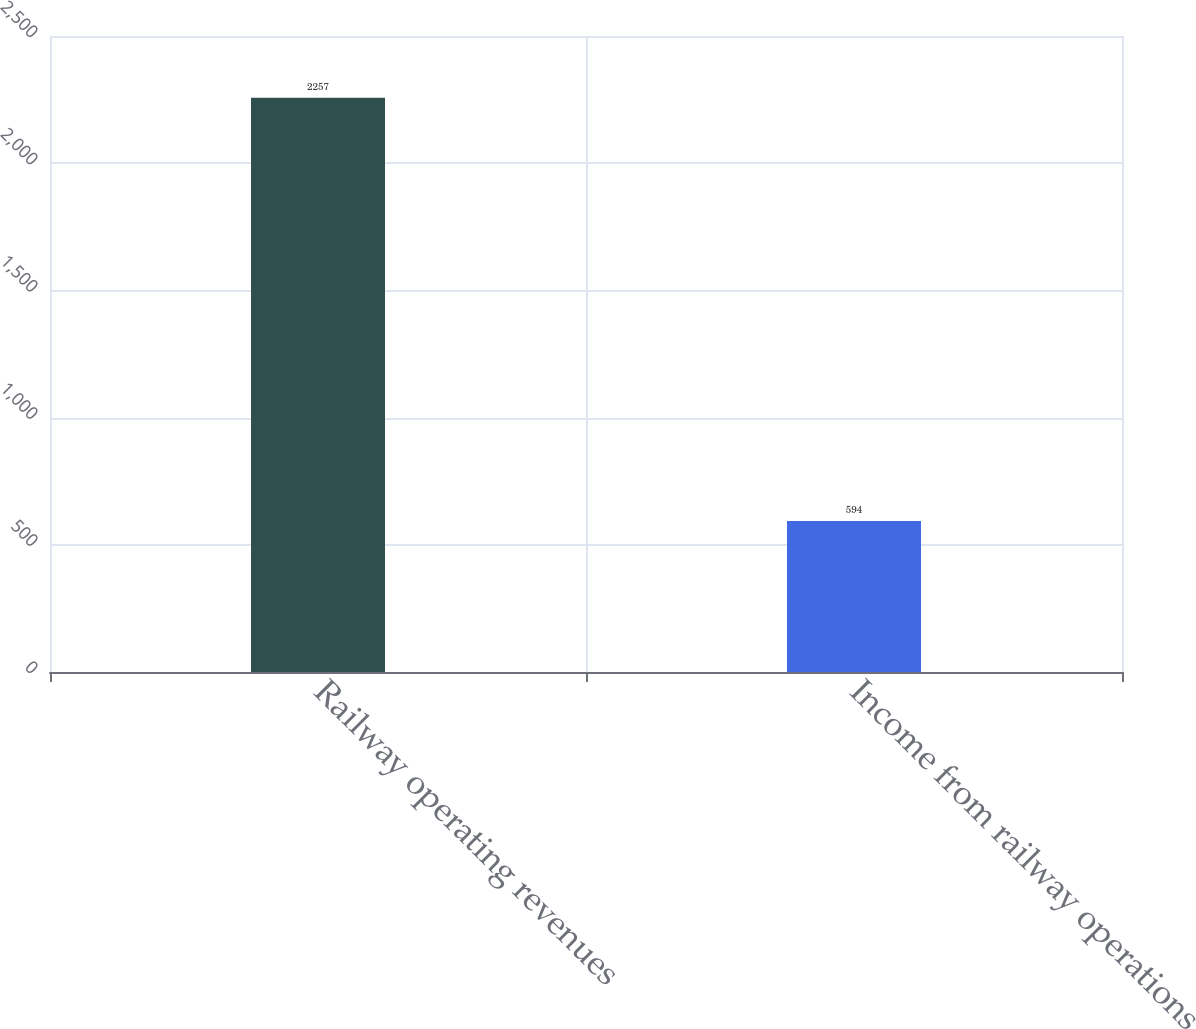Convert chart. <chart><loc_0><loc_0><loc_500><loc_500><bar_chart><fcel>Railway operating revenues<fcel>Income from railway operations<nl><fcel>2257<fcel>594<nl></chart> 